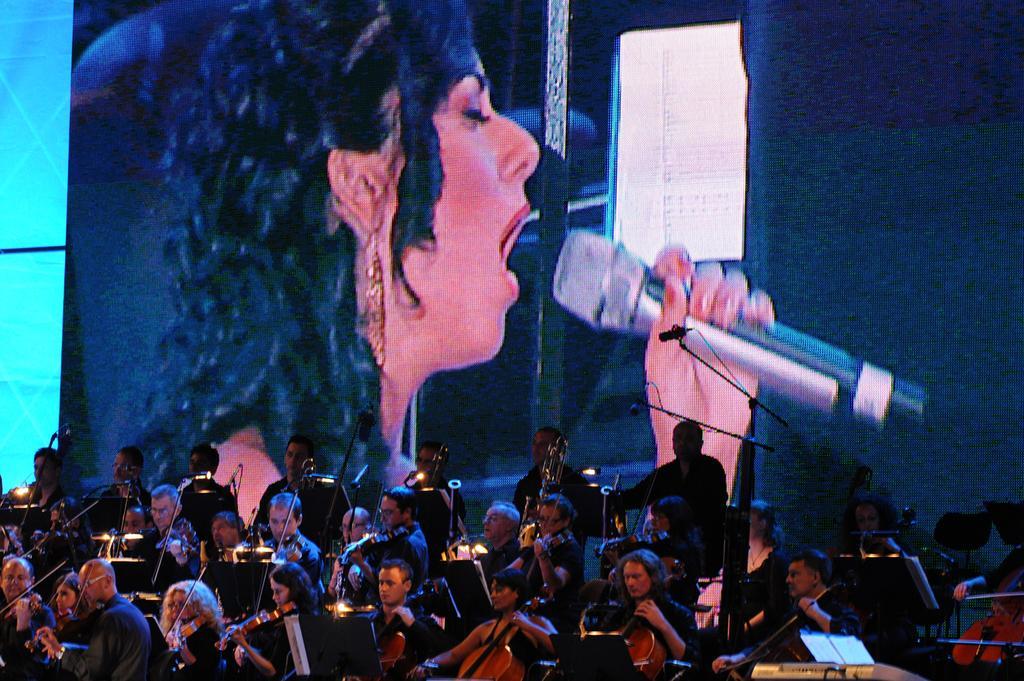In one or two sentences, can you explain what this image depicts? There are group of people sitting on the chairs and playing violin,behind them there is a huge screen and the picture of a woman is being displayed on the screen. She is singing a song. 